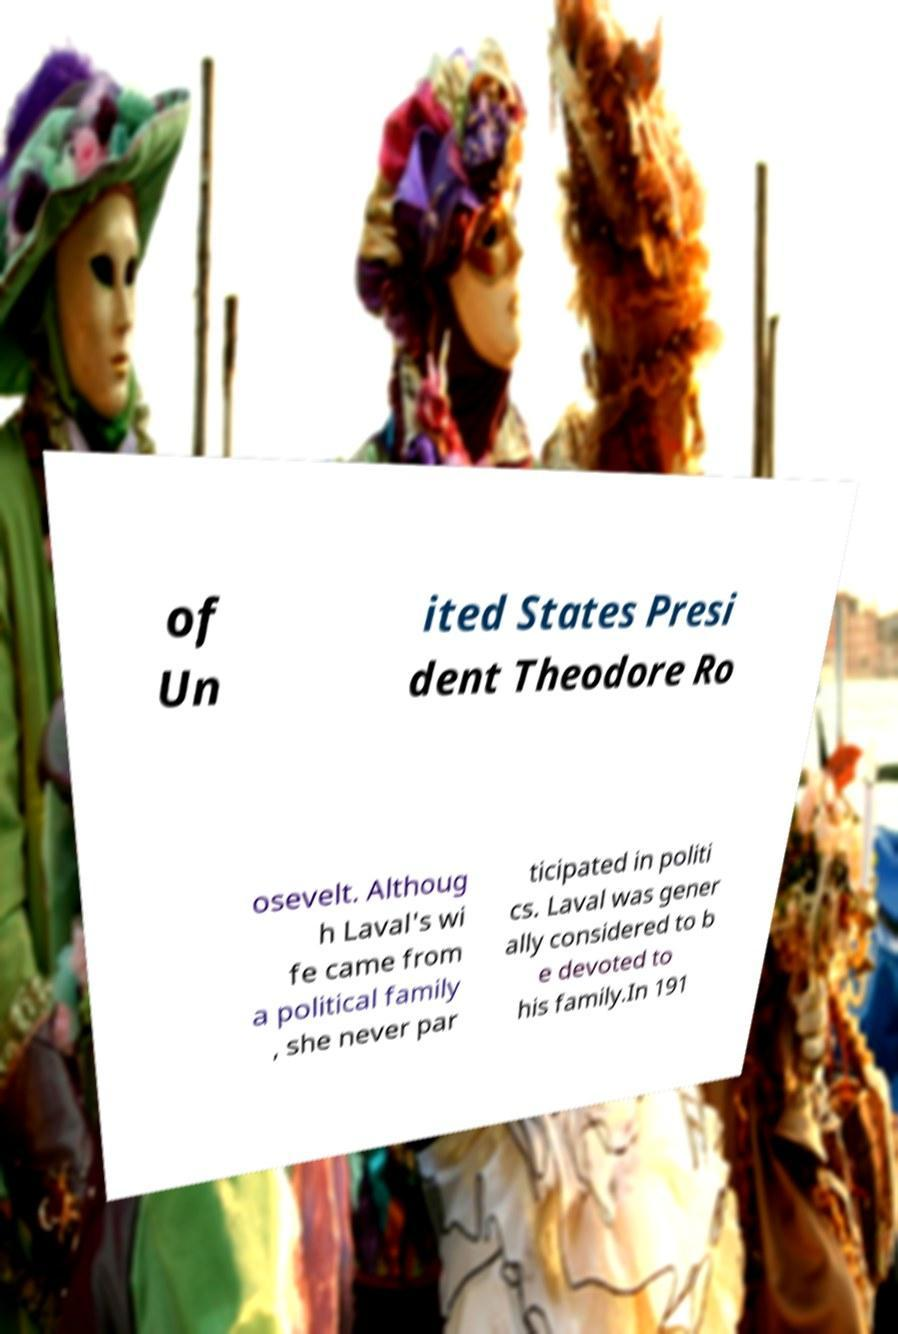I need the written content from this picture converted into text. Can you do that? of Un ited States Presi dent Theodore Ro osevelt. Althoug h Laval's wi fe came from a political family , she never par ticipated in politi cs. Laval was gener ally considered to b e devoted to his family.In 191 